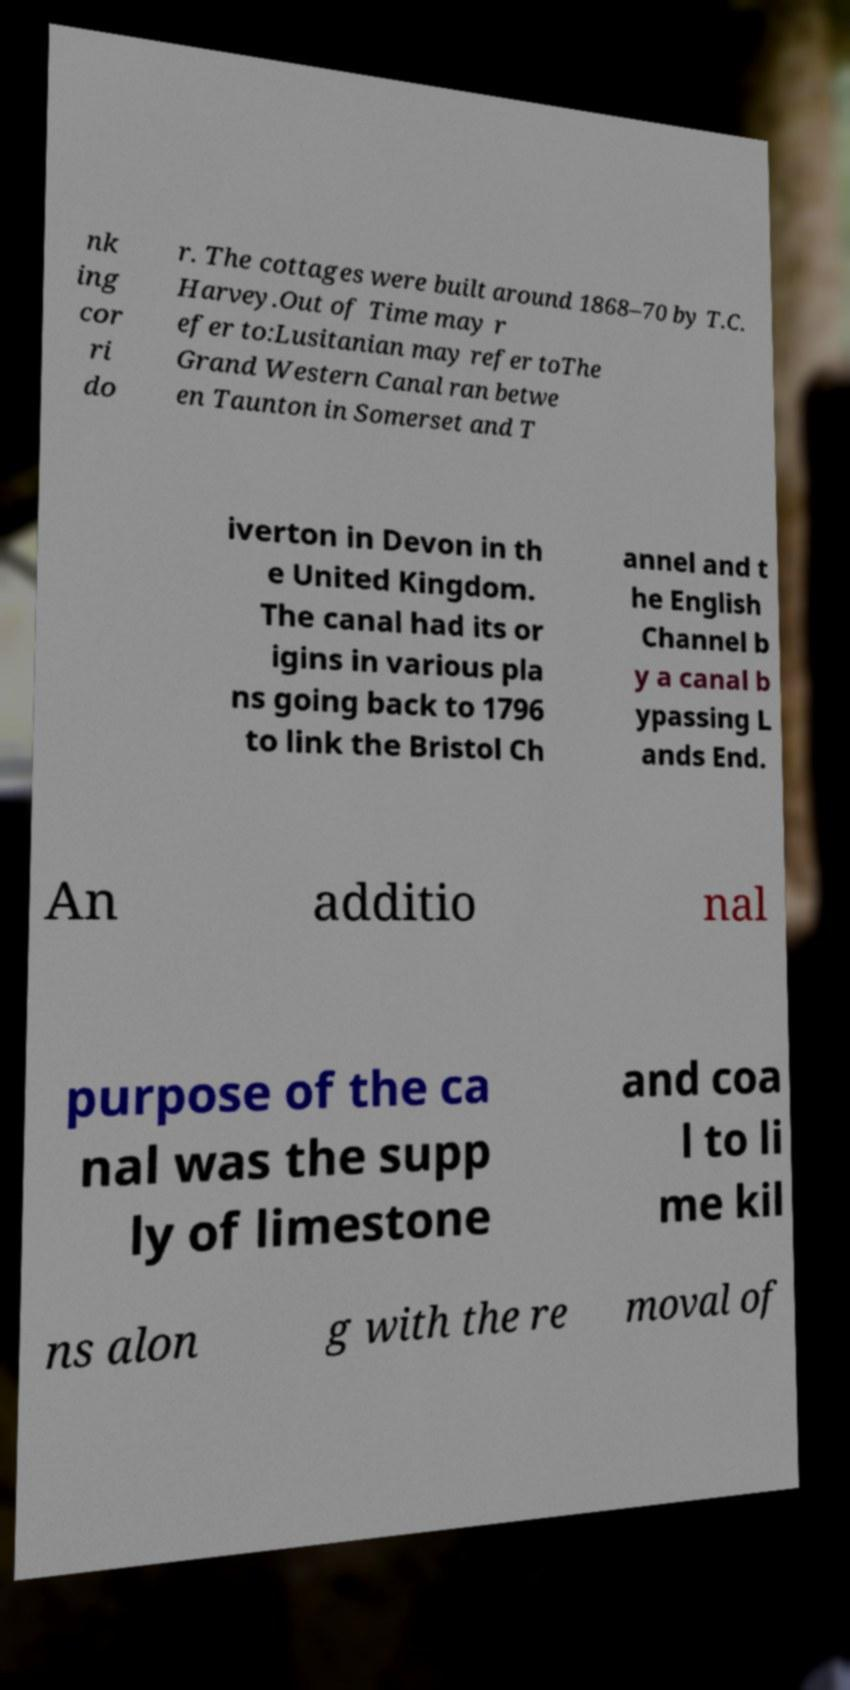I need the written content from this picture converted into text. Can you do that? nk ing cor ri do r. The cottages were built around 1868–70 by T.C. Harvey.Out of Time may r efer to:Lusitanian may refer toThe Grand Western Canal ran betwe en Taunton in Somerset and T iverton in Devon in th e United Kingdom. The canal had its or igins in various pla ns going back to 1796 to link the Bristol Ch annel and t he English Channel b y a canal b ypassing L ands End. An additio nal purpose of the ca nal was the supp ly of limestone and coa l to li me kil ns alon g with the re moval of 